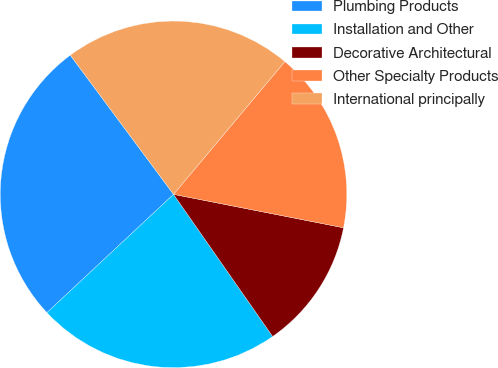<chart> <loc_0><loc_0><loc_500><loc_500><pie_chart><fcel>Plumbing Products<fcel>Installation and Other<fcel>Decorative Architectural<fcel>Other Specialty Products<fcel>International principally<nl><fcel>26.8%<fcel>22.73%<fcel>12.22%<fcel>16.98%<fcel>21.27%<nl></chart> 